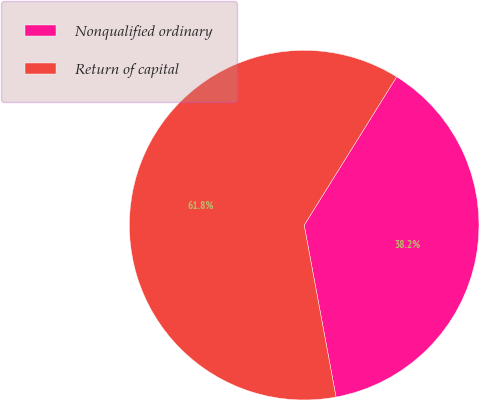<chart> <loc_0><loc_0><loc_500><loc_500><pie_chart><fcel>Nonqualified ordinary<fcel>Return of capital<nl><fcel>38.21%<fcel>61.79%<nl></chart> 